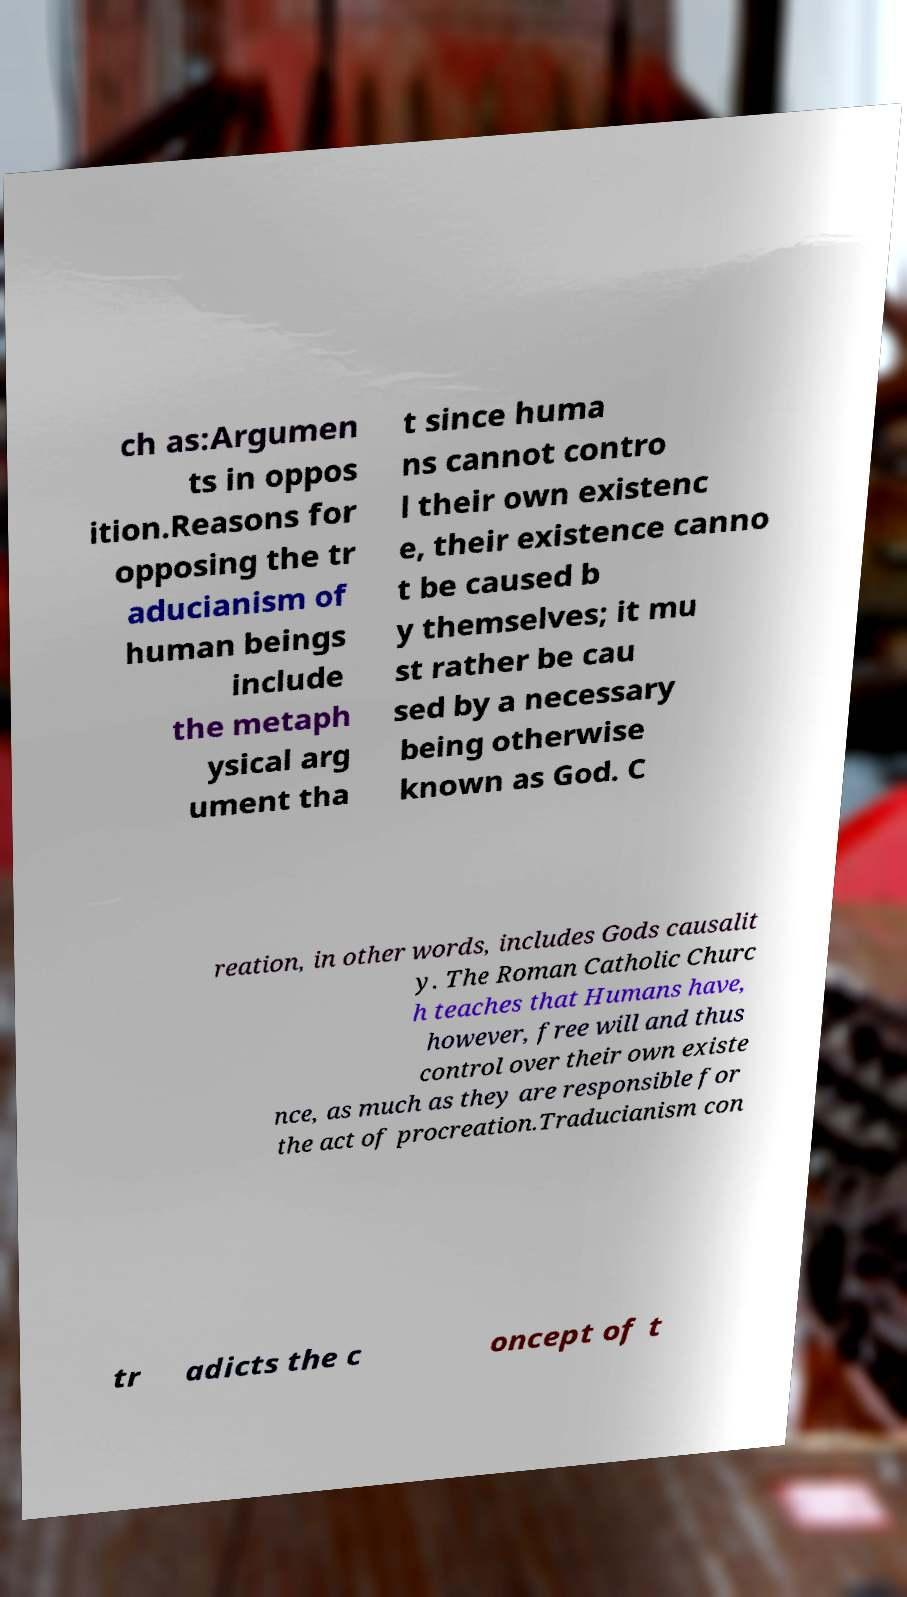Can you read and provide the text displayed in the image?This photo seems to have some interesting text. Can you extract and type it out for me? ch as:Argumen ts in oppos ition.Reasons for opposing the tr aducianism of human beings include the metaph ysical arg ument tha t since huma ns cannot contro l their own existenc e, their existence canno t be caused b y themselves; it mu st rather be cau sed by a necessary being otherwise known as God. C reation, in other words, includes Gods causalit y. The Roman Catholic Churc h teaches that Humans have, however, free will and thus control over their own existe nce, as much as they are responsible for the act of procreation.Traducianism con tr adicts the c oncept of t 